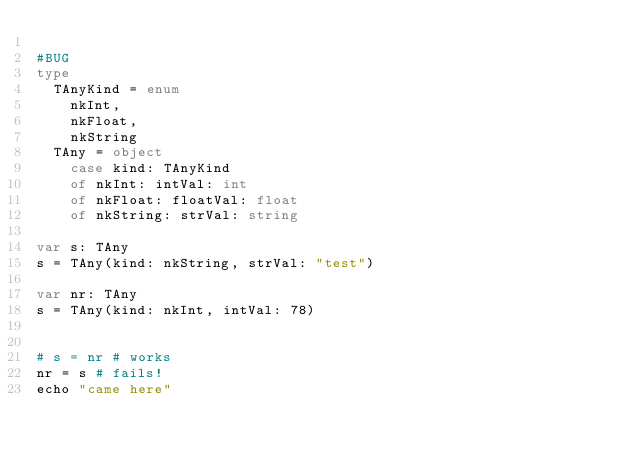<code> <loc_0><loc_0><loc_500><loc_500><_Nim_>
#BUG
type
  TAnyKind = enum
    nkInt,
    nkFloat,
    nkString
  TAny = object
    case kind: TAnyKind
    of nkInt: intVal: int
    of nkFloat: floatVal: float
    of nkString: strVal: string

var s: TAny
s = TAny(kind: nkString, strVal: "test")

var nr: TAny
s = TAny(kind: nkInt, intVal: 78)


# s = nr # works
nr = s # fails!
echo "came here"
</code> 